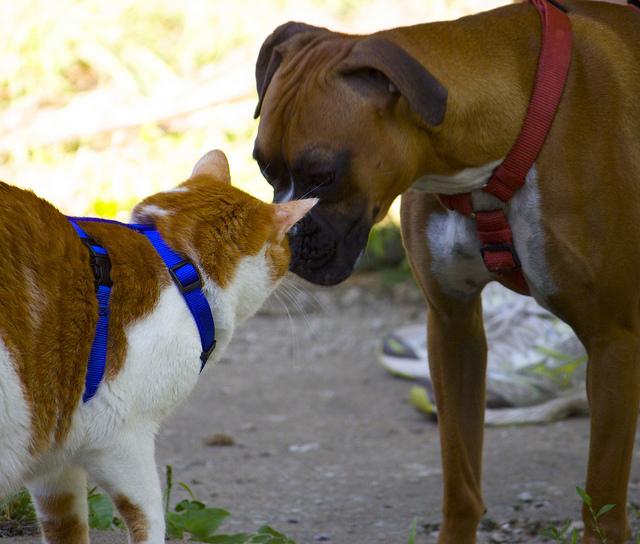Are the animals friends?
Concise answer only. Yes. Why is the cat wearing the blue collar?
Keep it brief. Harness. How many shoes do you see?
Quick response, please. 2. 